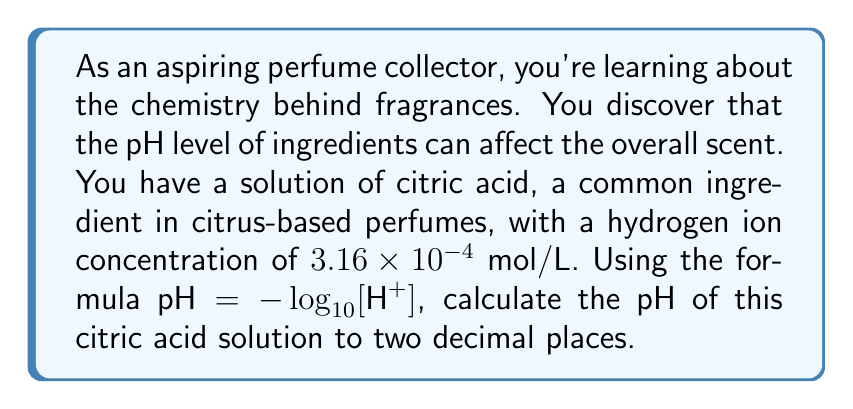Can you solve this math problem? Let's approach this step-by-step:

1) We're given the formula for pH: 
   $$\text{pH} = -\log_{10}[\text{H}^+]$$

2) We know the hydrogen ion concentration $[\text{H}^+] = 3.16 \times 10^{-4}$ mol/L

3) Let's substitute this into our equation:
   $$\text{pH} = -\log_{10}(3.16 \times 10^{-4})$$

4) To solve this, we can use the properties of logarithms. Specifically:
   $$\log_a(x \times 10^n) = \log_a(x) + n$$

5) Applying this to our problem:
   $$\text{pH} = -(\log_{10}(3.16) + \log_{10}(10^{-4}))$$

6) We know that $\log_{10}(10^{-4}) = -4$, so:
   $$\text{pH} = -(\log_{10}(3.16) - 4)$$

7) Using a calculator, we can find that $\log_{10}(3.16) \approx 0.4997$

8) Substituting this in:
   $$\text{pH} = -(0.4997 - 4) = 3.5003$$

9) Rounding to two decimal places:
   $$\text{pH} \approx 3.50$$
Answer: The pH of the citric acid solution is approximately 3.50. 